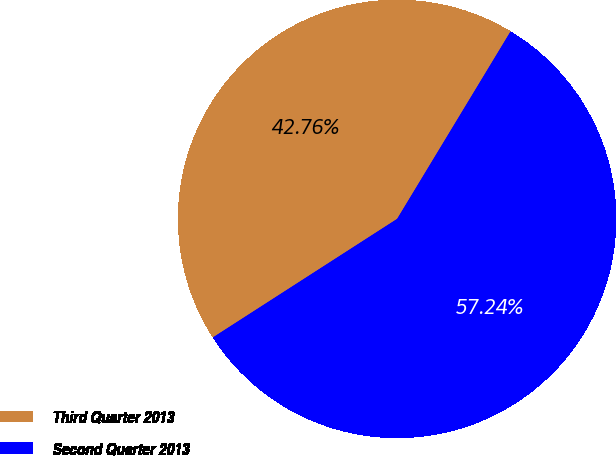<chart> <loc_0><loc_0><loc_500><loc_500><pie_chart><fcel>Third Quarter 2013<fcel>Second Quarter 2013<nl><fcel>42.76%<fcel>57.24%<nl></chart> 